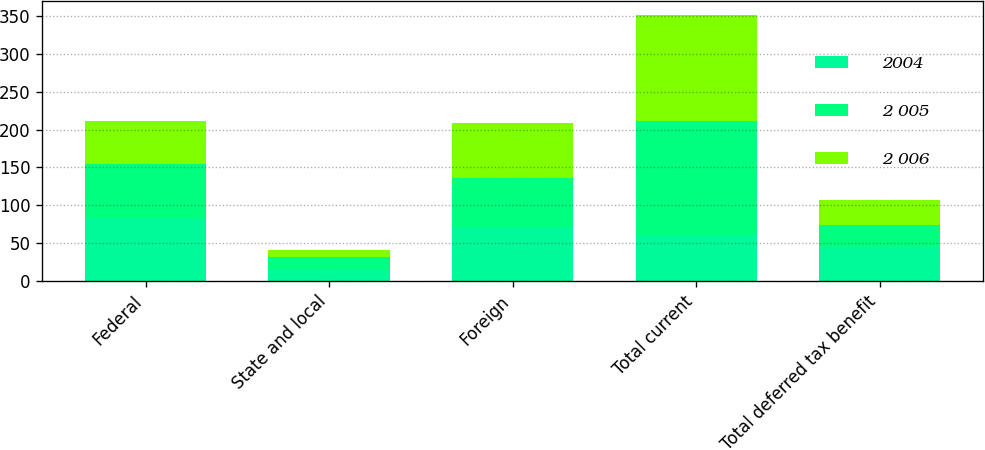Convert chart. <chart><loc_0><loc_0><loc_500><loc_500><stacked_bar_chart><ecel><fcel>Federal<fcel>State and local<fcel>Foreign<fcel>Total current<fcel>Total deferred tax benefit<nl><fcel>2004<fcel>83.7<fcel>16<fcel>71<fcel>61.3<fcel>44.7<nl><fcel>2 005<fcel>70.3<fcel>15.3<fcel>65<fcel>150.6<fcel>29.8<nl><fcel>2 006<fcel>57.6<fcel>9.4<fcel>73<fcel>140<fcel>32.7<nl></chart> 